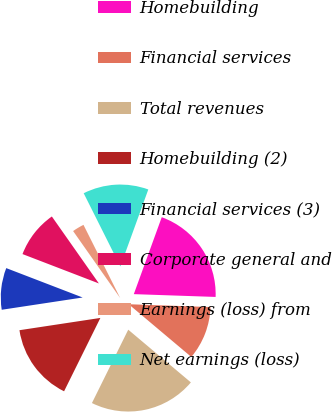<chart> <loc_0><loc_0><loc_500><loc_500><pie_chart><fcel>Homebuilding<fcel>Financial services<fcel>Total revenues<fcel>Homebuilding (2)<fcel>Financial services (3)<fcel>Corporate general and<fcel>Earnings (loss) from<fcel>Net earnings (loss)<nl><fcel>20.0%<fcel>10.59%<fcel>21.18%<fcel>15.29%<fcel>8.24%<fcel>9.41%<fcel>2.35%<fcel>12.94%<nl></chart> 